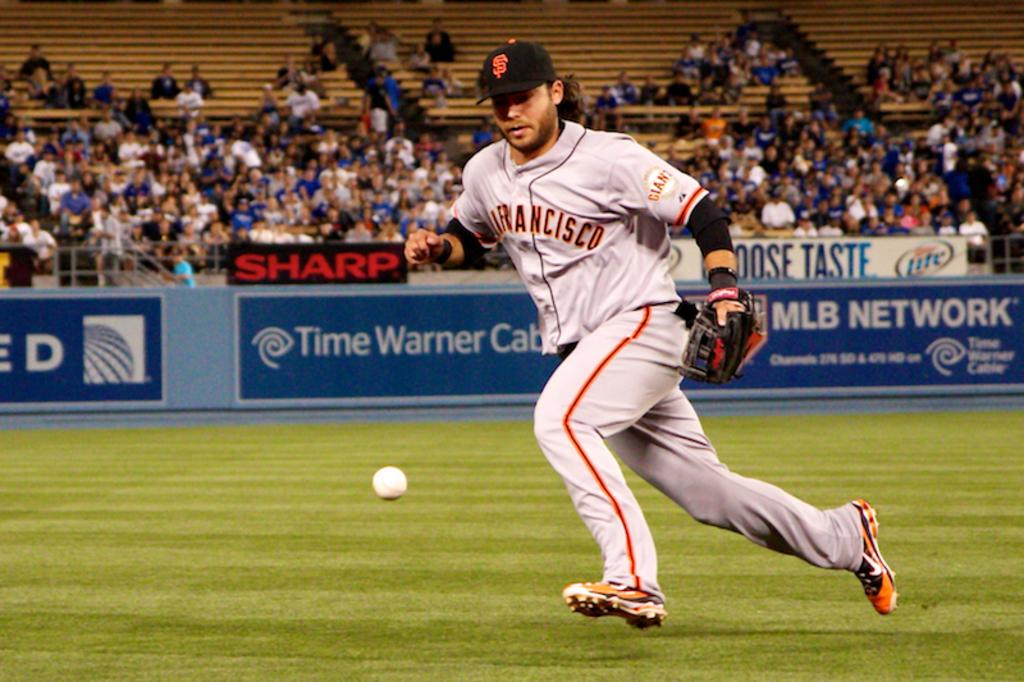<image>
Provide a brief description of the given image. a baseball player running after a ball in front of ads like SHARP 